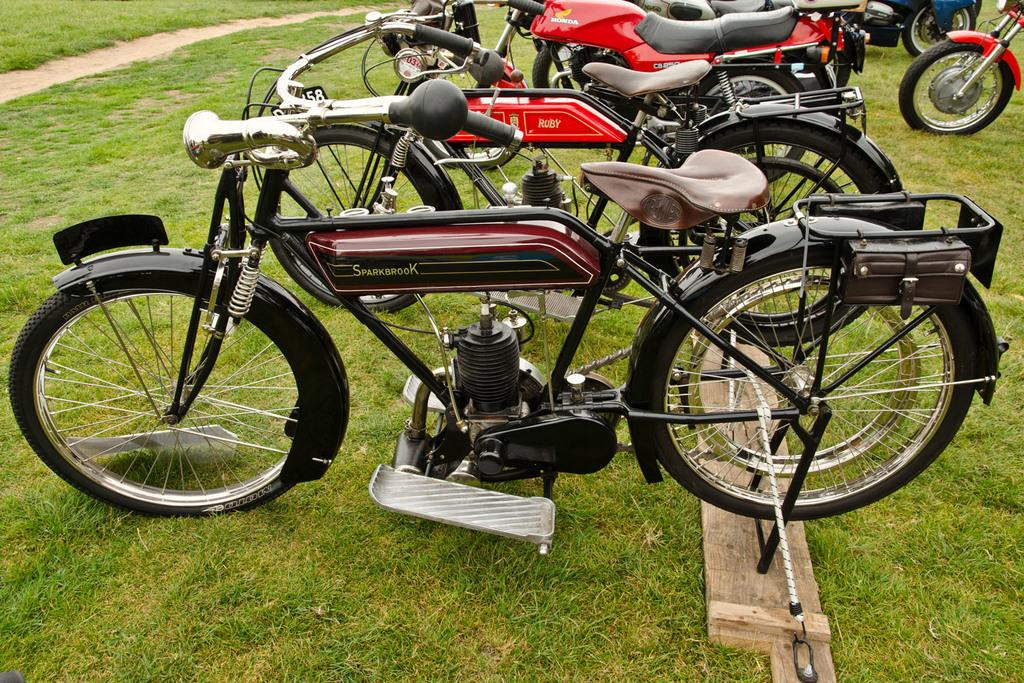What type of vehicles are parked on the ground in the image? There are bikes parked on the ground in the image. What is the color of the grass at the bottom of the image? There is green grass at the bottom of the image. Can you describe the color of one of the bikes in the image? One bike in the image is brown in color. What color are the bikes in the background of the image? In the background of the image, there are bikes in red color. Where is the apparatus used for scientific experiments in the image? There is no apparatus used for scientific experiments present in the image. Can you see a toad hopping on the green grass in the image? There is no toad present in the image. 